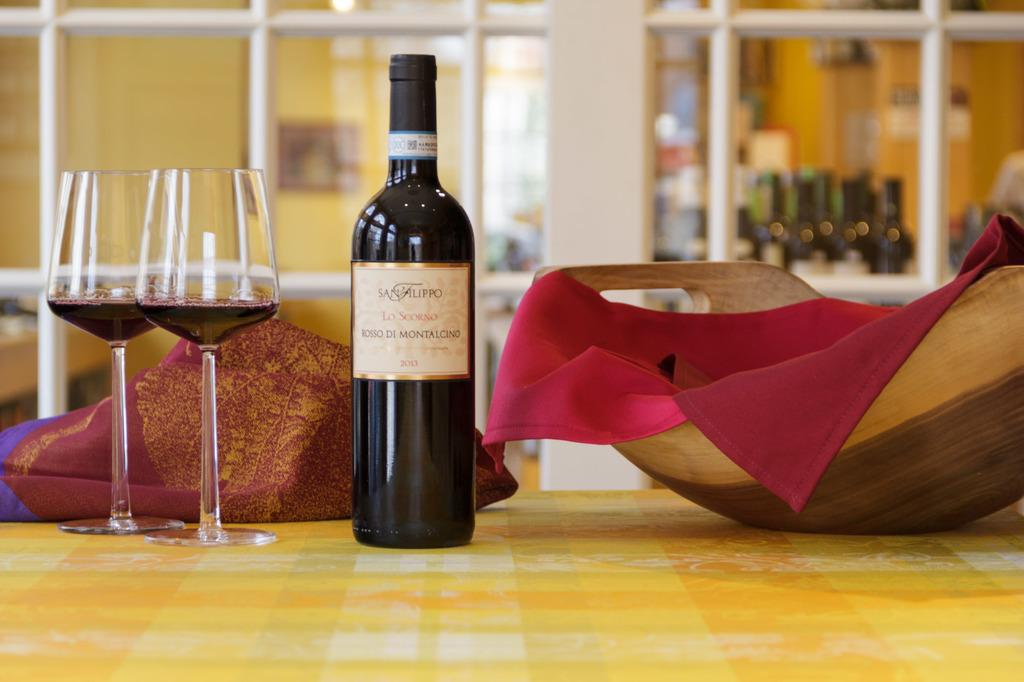Provide a one-sentence caption for the provided image. The type of wine shown here is Rosso Di Montalcino. 